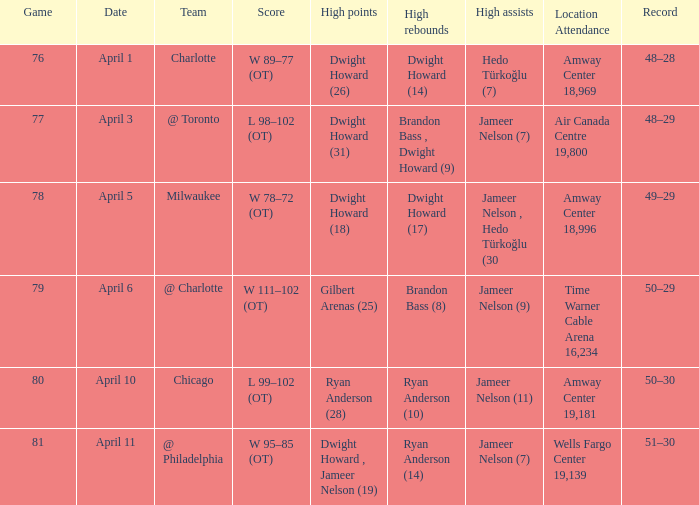Who had the most the most rebounds and how many did they have on April 1? Dwight Howard (14). 